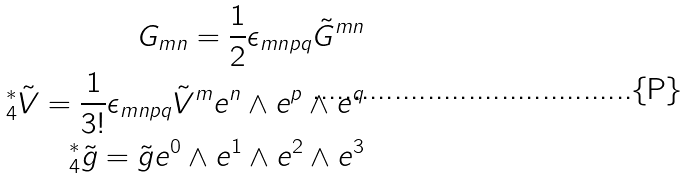<formula> <loc_0><loc_0><loc_500><loc_500>G _ { m n } = \frac { 1 } { 2 } \epsilon _ { m n p q } \tilde { G } ^ { m n } \\ ^ { * } _ { 4 } \tilde { V } = \frac { 1 } { 3 ! } \epsilon _ { m n p q } \tilde { V } ^ { m } e ^ { n } \wedge e ^ { p } \wedge e ^ { q } \\ ^ { * } _ { 4 } \tilde { g } = \tilde { g } e ^ { 0 } \wedge e ^ { 1 } \wedge e ^ { 2 } \wedge e ^ { 3 }</formula> 